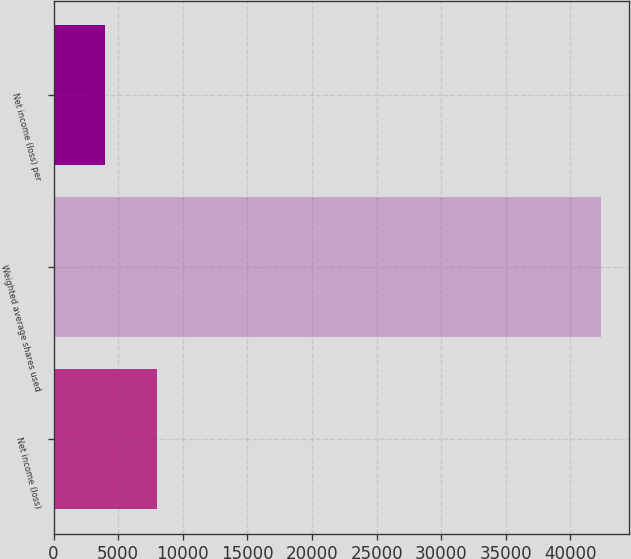Convert chart. <chart><loc_0><loc_0><loc_500><loc_500><bar_chart><fcel>Net income (loss)<fcel>Weighted average shares used<fcel>Net income (loss) per<nl><fcel>8034.44<fcel>42391.2<fcel>4017.24<nl></chart> 